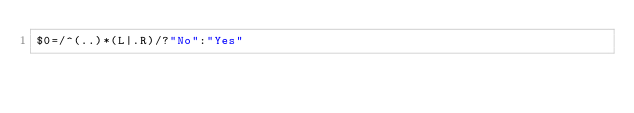<code> <loc_0><loc_0><loc_500><loc_500><_Awk_>$0=/^(..)*(L|.R)/?"No":"Yes"</code> 